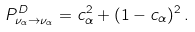Convert formula to latex. <formula><loc_0><loc_0><loc_500><loc_500>P ^ { D } _ { \nu _ { \alpha } \to \nu _ { \alpha } } = c _ { \alpha } ^ { 2 } + ( 1 - c _ { \alpha } ) ^ { 2 } \, .</formula> 